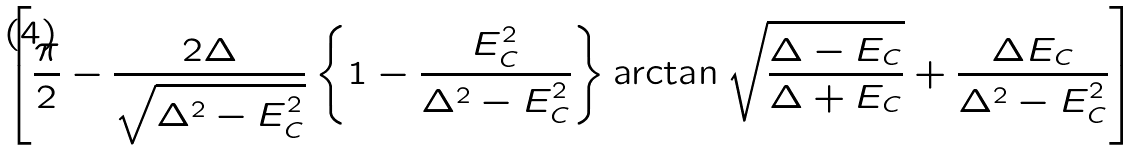Convert formula to latex. <formula><loc_0><loc_0><loc_500><loc_500>\left [ \frac { \pi } { 2 } - \frac { 2 \Delta } { \sqrt { \Delta ^ { 2 } - E _ { C } ^ { 2 } } } \left \{ 1 - \frac { E _ { C } ^ { 2 } } { \Delta ^ { 2 } - E _ { C } ^ { 2 } } \right \} \arctan \sqrt { \frac { \Delta - E _ { C } } { \Delta + E _ { C } } } + \frac { \Delta E _ { C } } { \Delta ^ { 2 } - E _ { C } ^ { 2 } } \right ]</formula> 